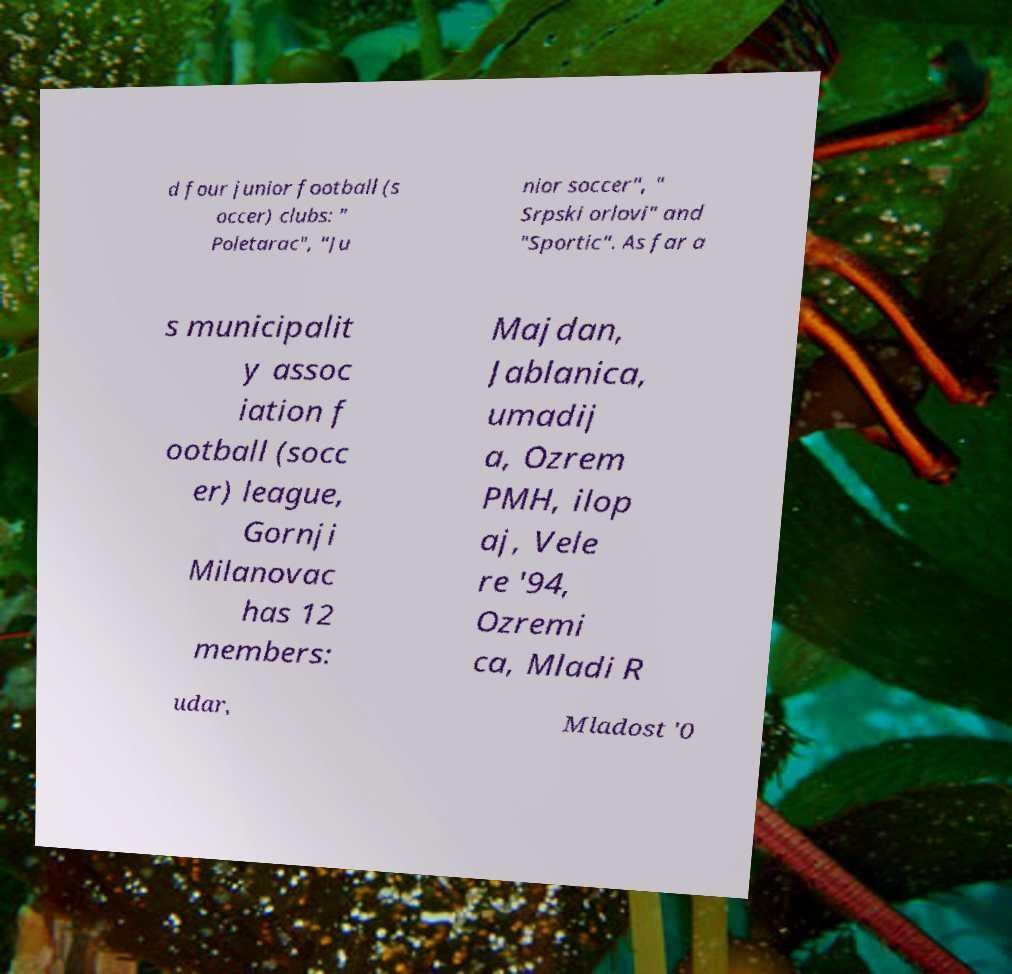Could you extract and type out the text from this image? d four junior football (s occer) clubs: " Poletarac", "Ju nior soccer", " Srpski orlovi" and "Sportic". As far a s municipalit y assoc iation f ootball (socc er) league, Gornji Milanovac has 12 members: Majdan, Jablanica, umadij a, Ozrem PMH, ilop aj, Vele re '94, Ozremi ca, Mladi R udar, Mladost '0 